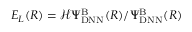<formula> <loc_0><loc_0><loc_500><loc_500>E _ { L } ( R ) = \mathcal { H } \Psi _ { D N N } ^ { B } ( R ) / \Psi _ { D N N } ^ { B } ( R )</formula> 